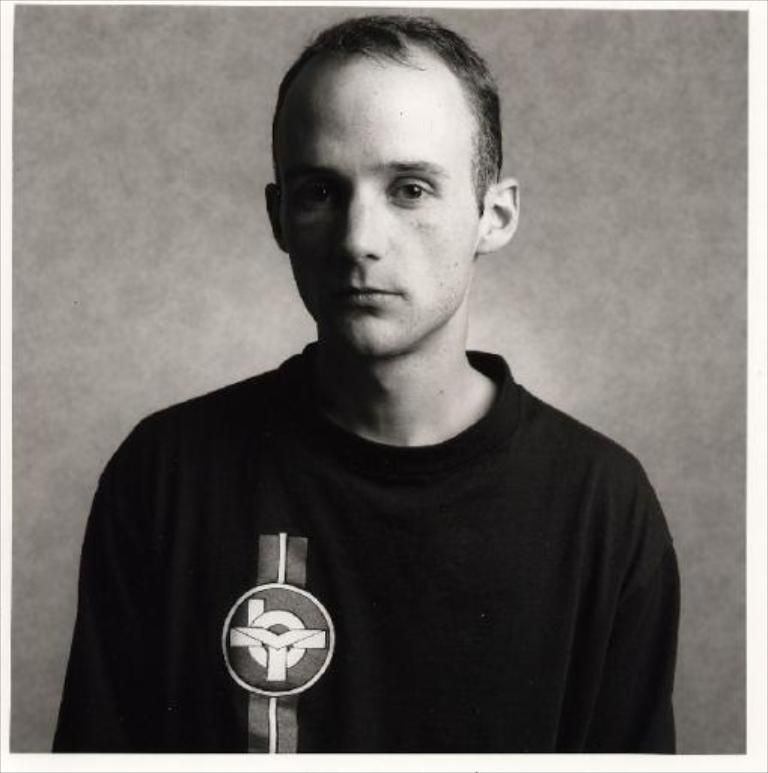What is present in the image? There is a man in the image. What is the man wearing? The man is wearing a black t-shirt. What type of hook can be seen in the image? There is no hook present in the image; it features a man wearing a black t-shirt. 